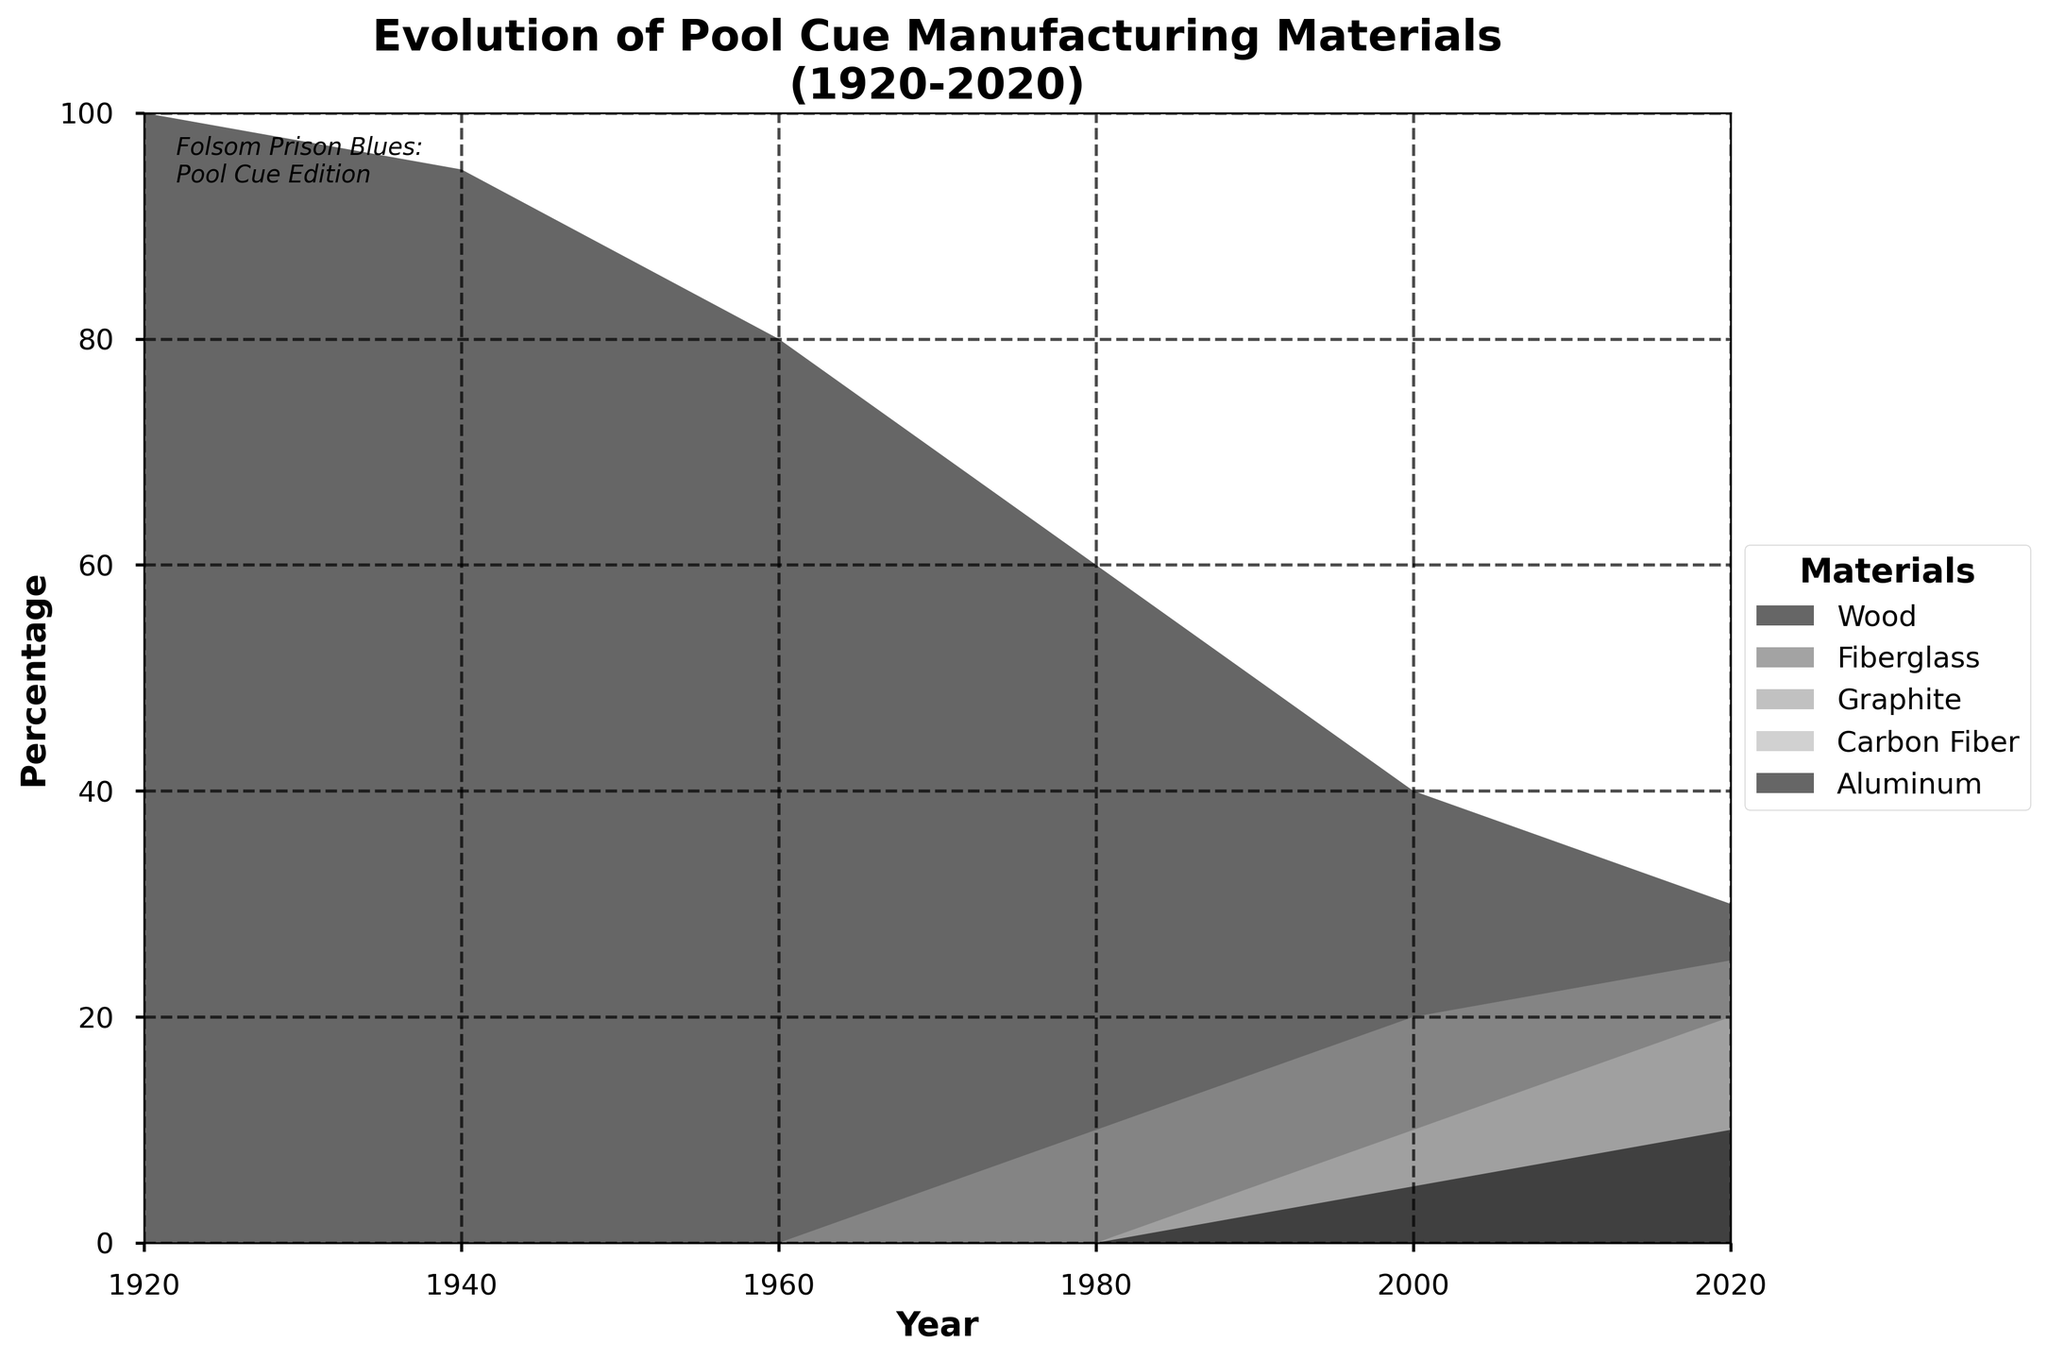What is the title of the figure? The title of the figure is written at the top and usually gives a summary of what the figure represents. In this case, it explains that the figure shows the evolution of pool cue manufacturing materials from 1920 to 2020.
Answer: Evolution of Pool Cue Manufacturing Materials (1920-2020) What material had the highest percentage in 1920? Looking at the leftmost part of the figure (for the year 1920), the material with the largest filled area, indicating the highest percentage, is Wood.
Answer: Wood How did the percentage of Carbon Fiber change from 2000 to 2020? To determine the change, note the percentage of Carbon Fiber in 2000 and compare it with its percentage in 2020. The figure shows an increase.
Answer: Increased Which two materials had the same percentage in the year 2000? By observing the proportions on the x-axis corresponding to the year 2000, we see that both Fiberglass and Graphite have similar filled areas, indicating equal percentages.
Answer: Fiberglass and Graphite What percentage of Aluminum was used in 1920? In 1920, Aluminum was not used in the manufacturing of pool cues, as indicated by the absence of a filled area for Aluminum in that year.
Answer: 0% Between 1980 and 2000, which material’s percentage reduced the most? To find the material with the largest reduction, compare the filled areas for each material between the years 1980 and 2000. Wood shows the most significant decrease.
Answer: Wood In what decade did Graphite first appear in pool cue manufacturing? Examining the figure, Graphite first appears in the year 1980, so the relevant decade is the 1980s.
Answer: 1980s What can you infer about the trend of using Wood as a material from 1920 to 2020? Notice the steadily decreasing trend in the filled area for Wood from left to right (1920 to 2020), indicating a consistent decrease in its use.
Answer: Decreasing By 2020, which material had the second highest percentage? In the year 2020, the material with the second largest filled area, after Wood, is Graphite.
Answer: Graphite 